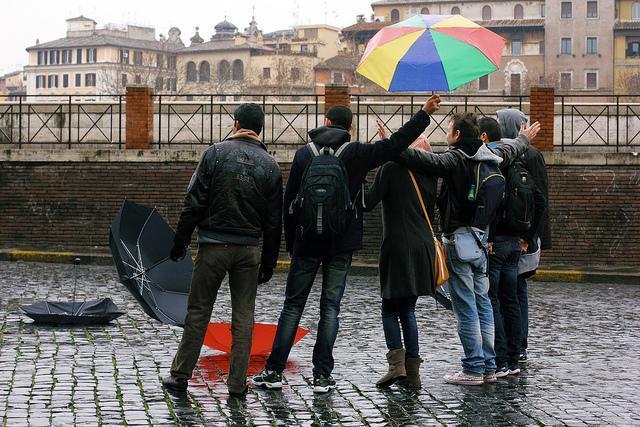How many people are in the picture?
Give a very brief answer. 6. How many colors are in the umbrella being held over the group's heads?
Give a very brief answer. 4. How many umbrellas are in the picture?
Give a very brief answer. 4. How many umbrellas are there?
Give a very brief answer. 4. How many umbrellas can be seen?
Give a very brief answer. 3. How many people are there?
Give a very brief answer. 6. How many backpacks can be seen?
Give a very brief answer. 3. How many zebras are facing forward?
Give a very brief answer. 0. 